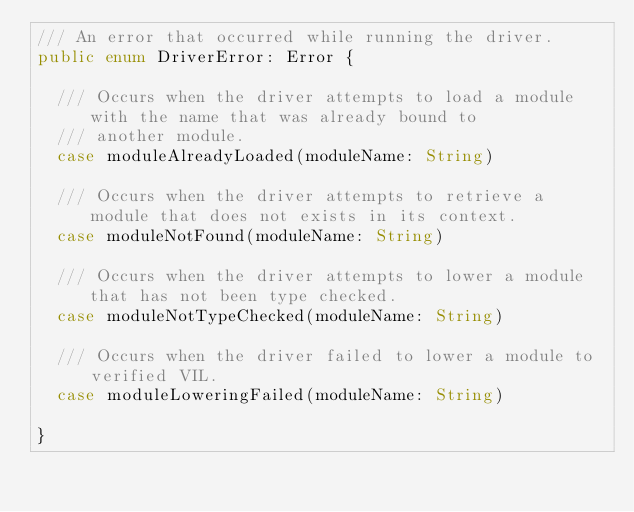<code> <loc_0><loc_0><loc_500><loc_500><_Swift_>/// An error that occurred while running the driver.
public enum DriverError: Error {

  /// Occurs when the driver attempts to load a module with the name that was already bound to
  /// another module.
  case moduleAlreadyLoaded(moduleName: String)

  /// Occurs when the driver attempts to retrieve a module that does not exists in its context.
  case moduleNotFound(moduleName: String)

  /// Occurs when the driver attempts to lower a module that has not been type checked.
  case moduleNotTypeChecked(moduleName: String)

  /// Occurs when the driver failed to lower a module to verified VIL.
  case moduleLoweringFailed(moduleName: String)

}
</code> 